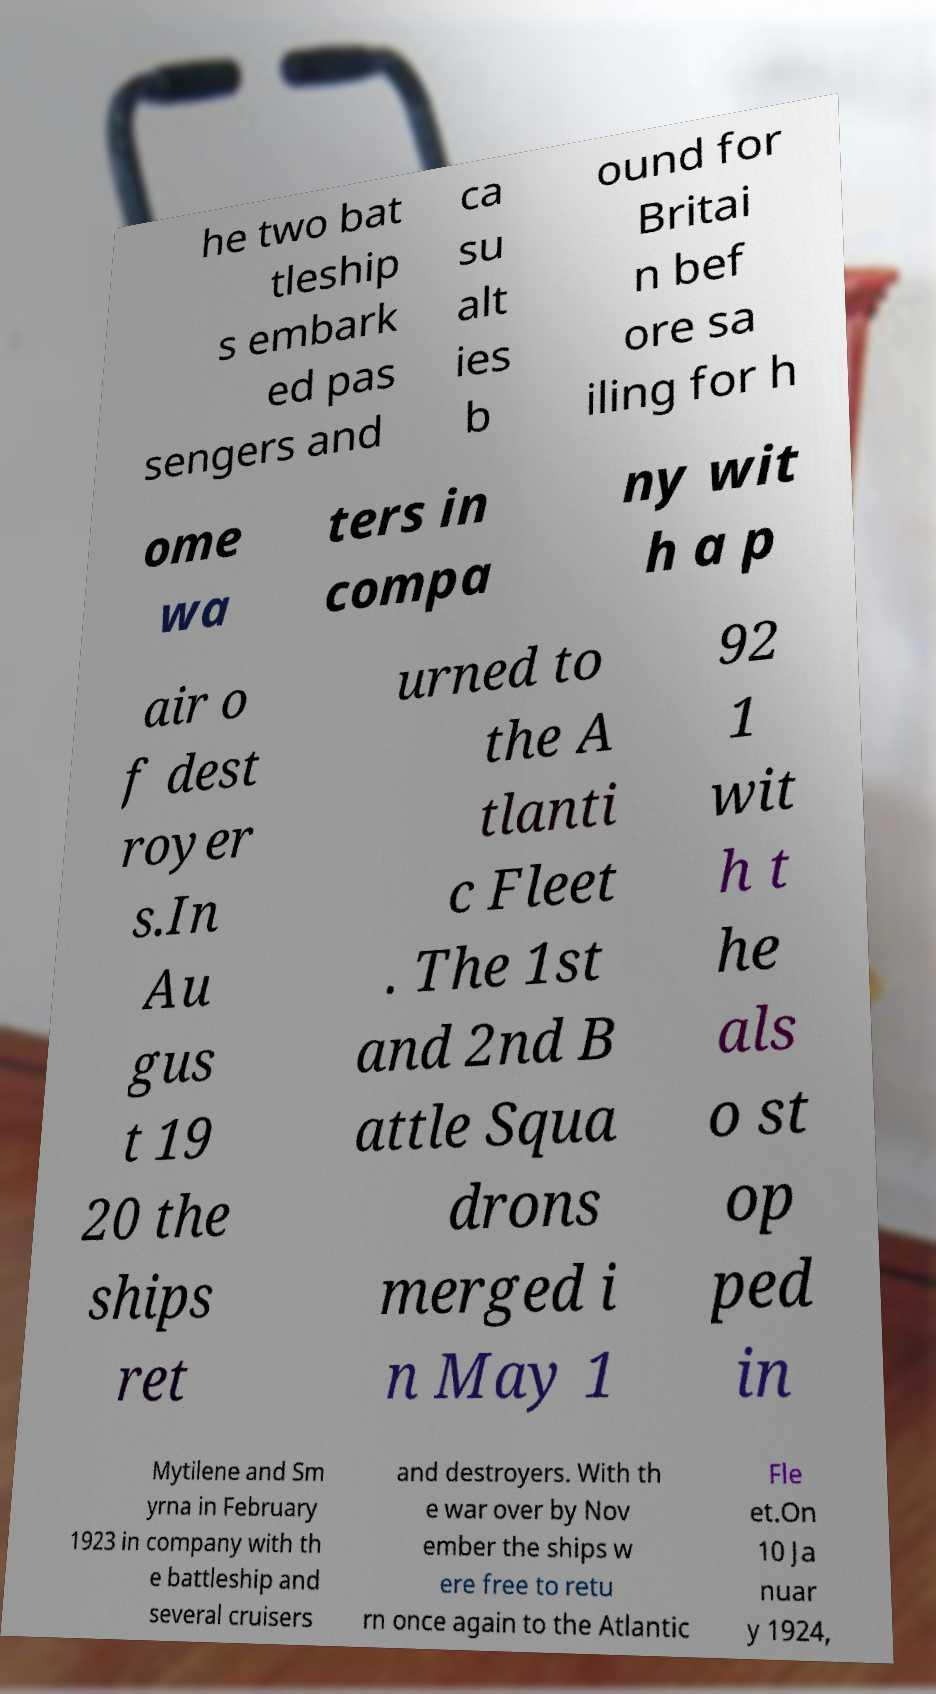Could you assist in decoding the text presented in this image and type it out clearly? he two bat tleship s embark ed pas sengers and ca su alt ies b ound for Britai n bef ore sa iling for h ome wa ters in compa ny wit h a p air o f dest royer s.In Au gus t 19 20 the ships ret urned to the A tlanti c Fleet . The 1st and 2nd B attle Squa drons merged i n May 1 92 1 wit h t he als o st op ped in Mytilene and Sm yrna in February 1923 in company with th e battleship and several cruisers and destroyers. With th e war over by Nov ember the ships w ere free to retu rn once again to the Atlantic Fle et.On 10 Ja nuar y 1924, 